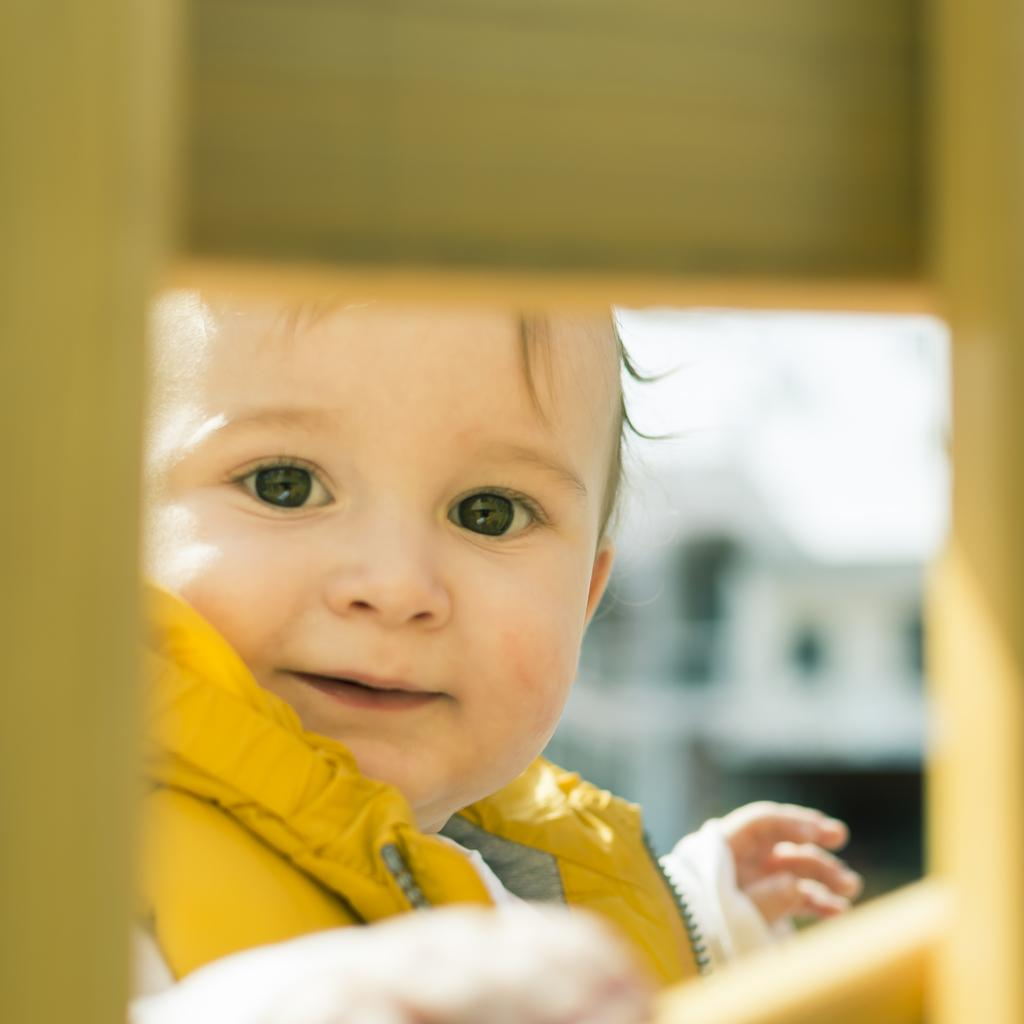What is the main subject of the image? The main subject of the image is a kid. What can be observed about the kid's attire? The kid is wearing clothes. What type of bear can be seen interacting with the kid in the image? There is no bear present in the image; it only features a kid wearing clothes. What language is the kid speaking in the image? The language the kid is speaking cannot be determined from the image, as there is no audio or text present. 